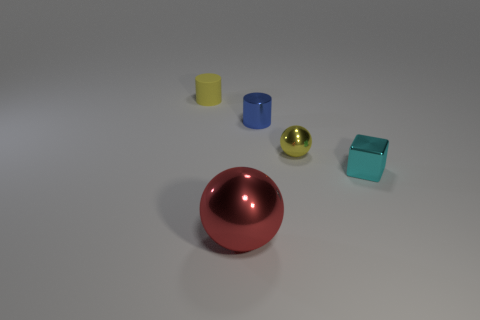There is another tiny blue object that is the same shape as the tiny rubber object; what is its material?
Make the answer very short. Metal. Are there any other things that have the same material as the small yellow cylinder?
Offer a very short reply. No. The metallic cylinder has what color?
Provide a succinct answer. Blue. Does the tiny matte object have the same color as the tiny sphere?
Offer a very short reply. Yes. How many rubber cylinders are on the right side of the thing in front of the cyan metallic block?
Ensure brevity in your answer.  0. How big is the thing that is left of the tiny yellow sphere and right of the big red thing?
Provide a succinct answer. Small. What material is the object that is to the left of the red metal thing?
Make the answer very short. Rubber. Are there any small objects that have the same shape as the large metallic thing?
Provide a succinct answer. Yes. What number of red shiny things have the same shape as the matte thing?
Your response must be concise. 0. There is a metallic sphere in front of the tiny block; is it the same size as the object on the right side of the small metal sphere?
Offer a very short reply. No. 